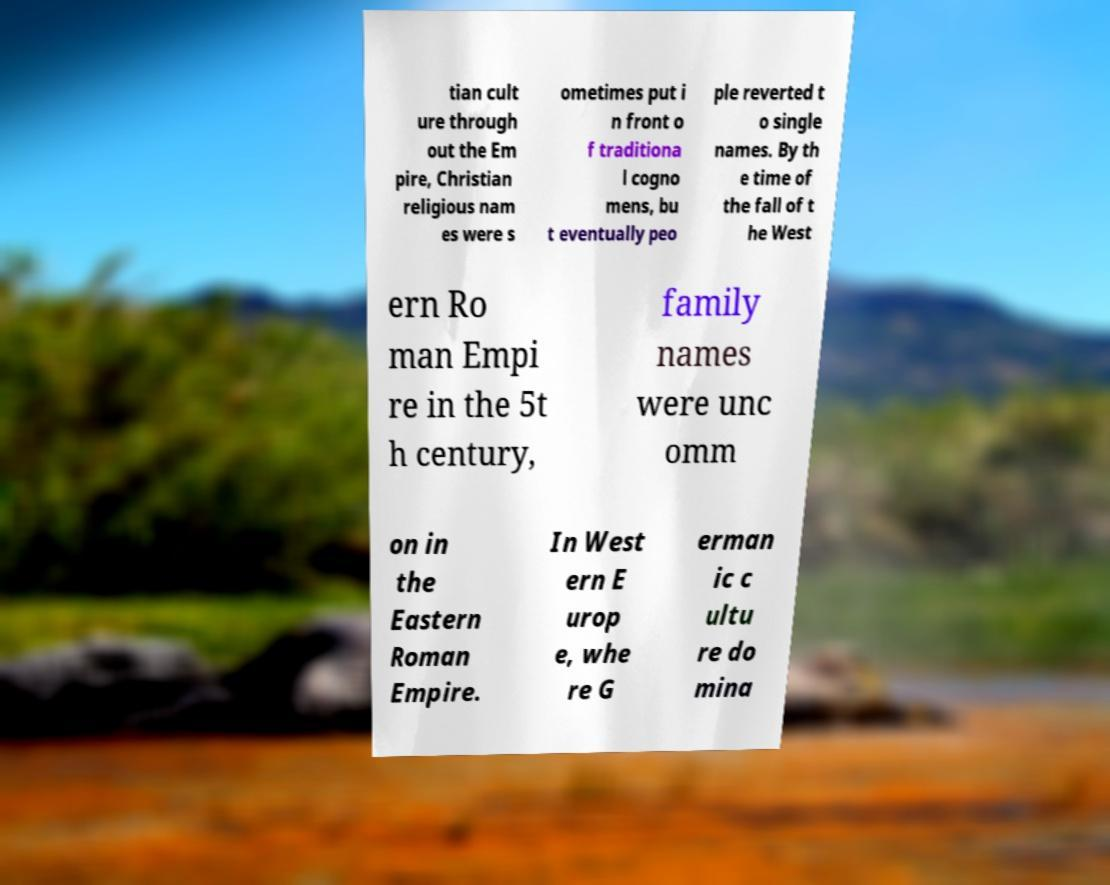I need the written content from this picture converted into text. Can you do that? tian cult ure through out the Em pire, Christian religious nam es were s ometimes put i n front o f traditiona l cogno mens, bu t eventually peo ple reverted t o single names. By th e time of the fall of t he West ern Ro man Empi re in the 5t h century, family names were unc omm on in the Eastern Roman Empire. In West ern E urop e, whe re G erman ic c ultu re do mina 